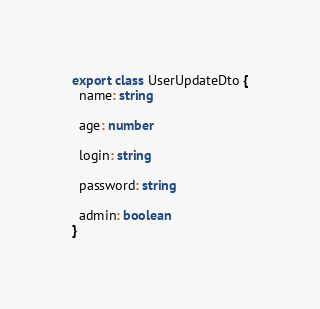<code> <loc_0><loc_0><loc_500><loc_500><_TypeScript_>export class UserUpdateDto {
  name: string

  age: number

  login: string

  password: string

  admin: boolean
}</code> 